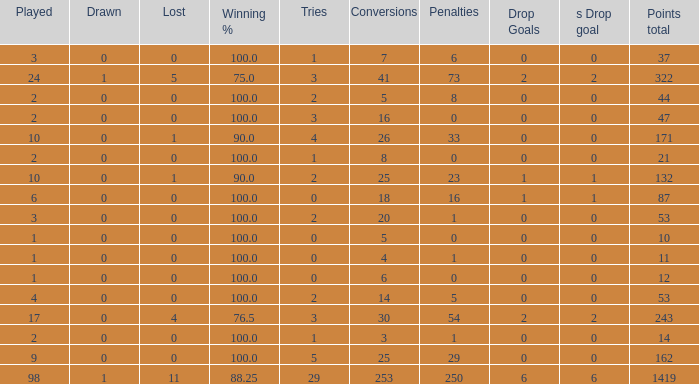How many ties did he have when he had 1 penalties and more than 20 conversions? None. 